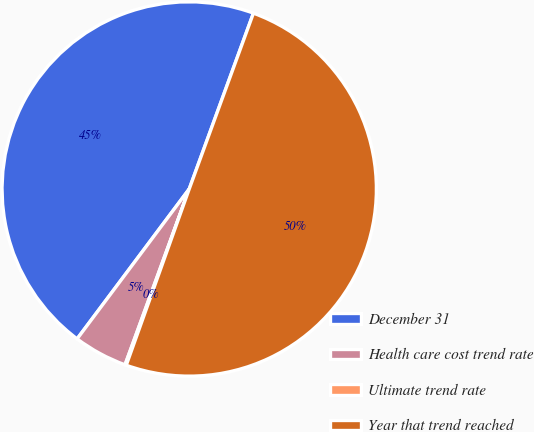Convert chart to OTSL. <chart><loc_0><loc_0><loc_500><loc_500><pie_chart><fcel>December 31<fcel>Health care cost trend rate<fcel>Ultimate trend rate<fcel>Year that trend reached<nl><fcel>45.35%<fcel>4.65%<fcel>0.11%<fcel>49.89%<nl></chart> 